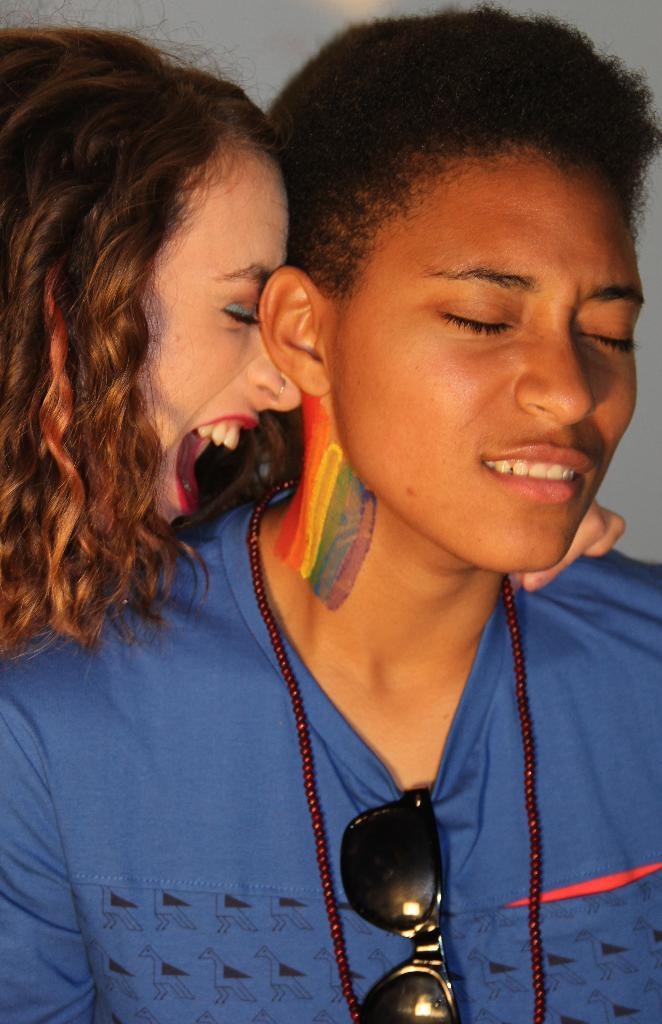How many people are in the image? There are two persons in the image. What is the person wearing on the top? One person is wearing a blue color t-shirt. What protective gear can be seen in the image? Goggles are visible in the image. What is in the background of the image? There is a wall in the background of the image. What is the person's wish at the hour of 3 pm in the image? There is no information about the person's wish or the time in the image, so we cannot answer this question. 